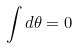<formula> <loc_0><loc_0><loc_500><loc_500>\int d \theta = 0</formula> 